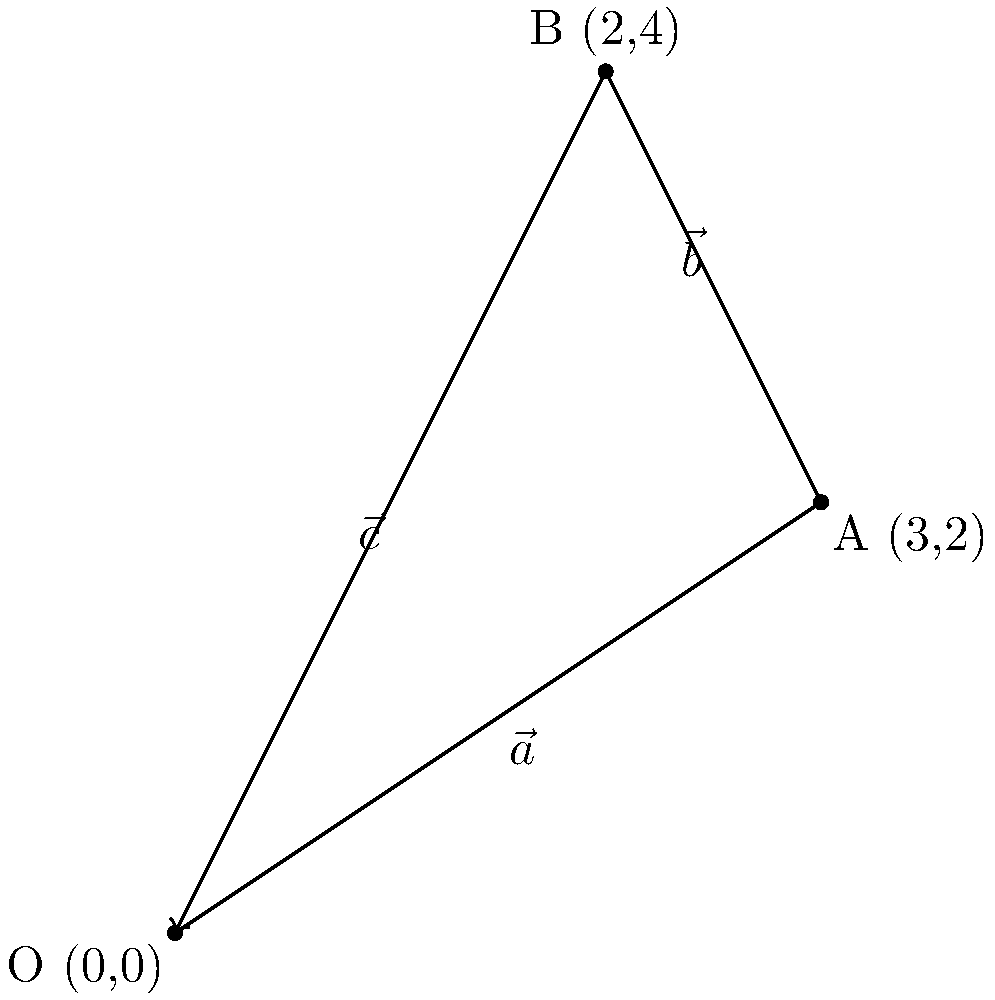In creating a complex Kashmiri shawl pattern, a weaver moves the shuttle from the origin O to point A, then from A to B. If $\vec{a} = 3\hat{i} + 2\hat{j}$ represents the first movement and $\vec{b} = -\hat{i} + 2\hat{j}$ represents the second movement, what is the vector $\vec{c}$ that represents the direct path from O to B? To find the vector $\vec{c}$ that represents the direct path from O to B, we need to add the two vectors $\vec{a}$ and $\vec{b}$. This is because $\vec{c}$ is the resultant vector of the two movements.

Step 1: Identify the given vectors
$\vec{a} = 3\hat{i} + 2\hat{j}$
$\vec{b} = -\hat{i} + 2\hat{j}$

Step 2: Add the vectors component-wise
$\vec{c} = \vec{a} + \vec{b}$
$\vec{c} = (3\hat{i} + 2\hat{j}) + (-\hat{i} + 2\hat{j})$

Step 3: Combine like terms
$\vec{c} = (3-1)\hat{i} + (2+2)\hat{j}$
$\vec{c} = 2\hat{i} + 4\hat{j}$

Therefore, the vector $\vec{c}$ that represents the direct path from O to B is $2\hat{i} + 4\hat{j}$.
Answer: $2\hat{i} + 4\hat{j}$ 